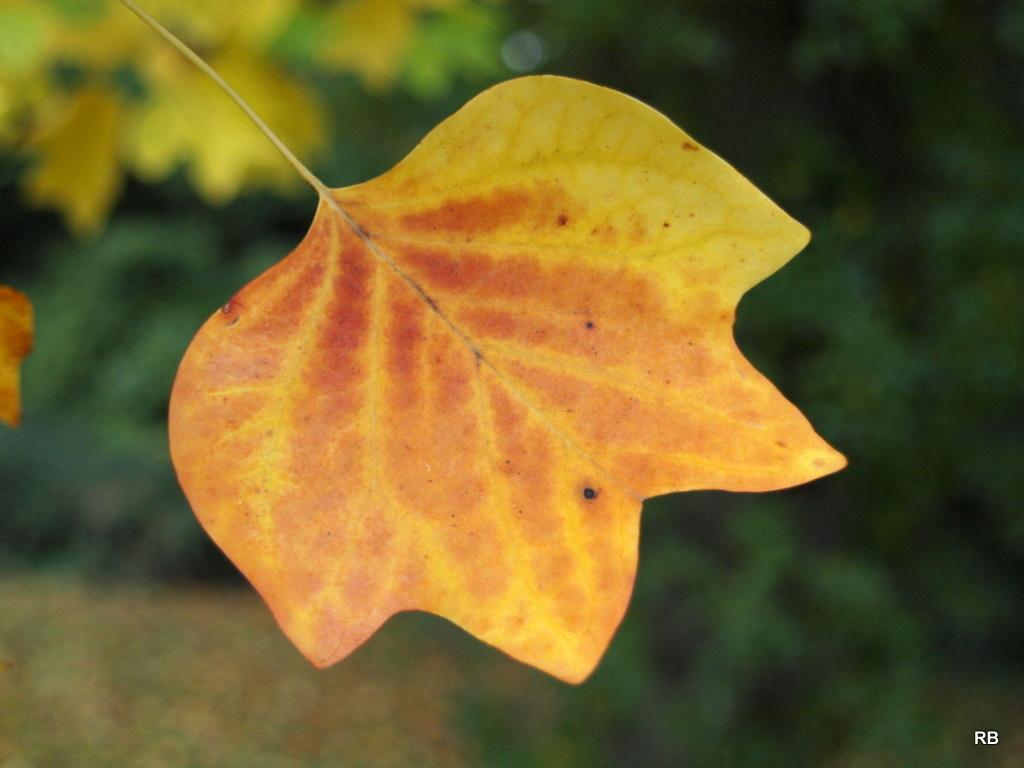What is the main subject of the image? There is a leaf in the center of the image. Can you describe the background of the image? There are plants in the background of the image. What type of flesh can be seen in the image? There is no flesh present in the image; it features a leaf and plants in the background. What selection of items is being made in the image? There is no selection process depicted in the image; it simply shows a leaf and plants. 